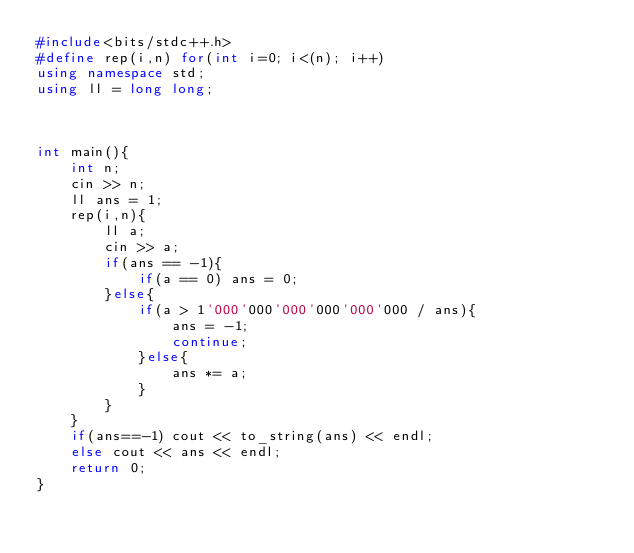Convert code to text. <code><loc_0><loc_0><loc_500><loc_500><_C++_>#include<bits/stdc++.h>
#define rep(i,n) for(int i=0; i<(n); i++)
using namespace std;
using ll = long long;



int main(){
	int n;
	cin >> n;
	ll ans = 1;
	rep(i,n){
		ll a;
		cin >> a;
		if(ans == -1){
			if(a == 0) ans = 0;
		}else{
			if(a > 1'000'000'000'000'000'000 / ans){
				ans = -1;
				continue;
			}else{
				ans *= a;
			}
		}
	}
	if(ans==-1) cout << to_string(ans) << endl;
	else cout << ans << endl;
	return 0;
}
</code> 